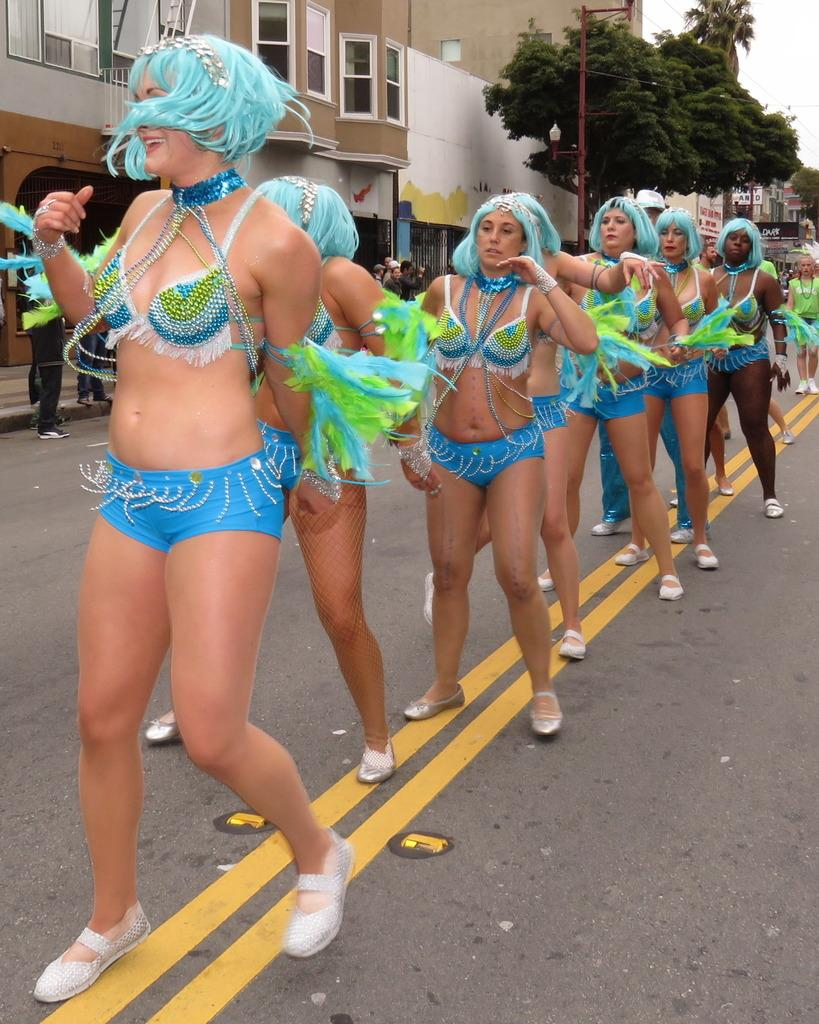Who is present in the image? There are women in the image. How are the women positioned in the image? The women are standing in a line. Where are the women located in the image? The women are on the road. What colors are the women wearing? The women are wearing a combination of blue and green colors. What can be seen on the left side of the image? There are buildings and trees visible on the left side of the image. Can you see any cobwebs in the image? There is no mention of cobwebs in the image, so we cannot determine if any are present. 